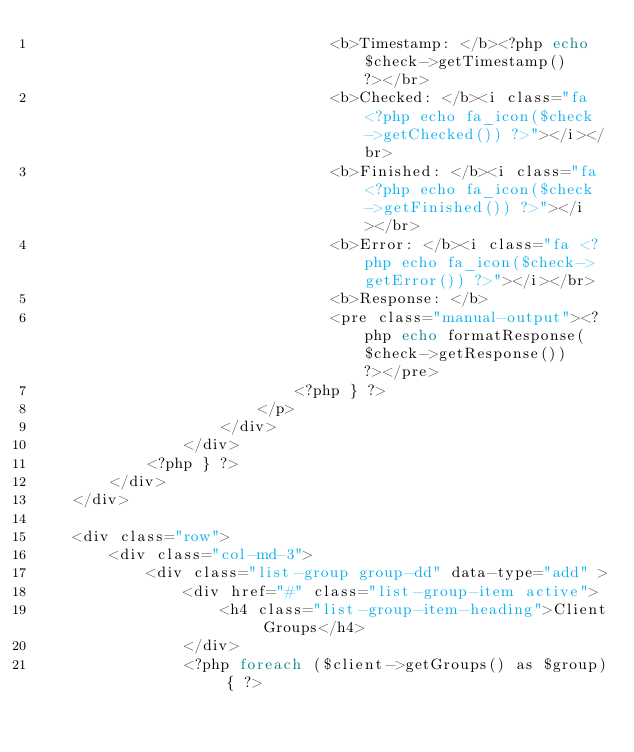<code> <loc_0><loc_0><loc_500><loc_500><_PHP_>                                <b>Timestamp: </b><?php echo $check->getTimestamp() ?></br>
                                <b>Checked: </b><i class="fa <?php echo fa_icon($check->getChecked()) ?>"></i></br>
                                <b>Finished: </b><i class="fa <?php echo fa_icon($check->getFinished()) ?>"></i></br>
                                <b>Error: </b><i class="fa <?php echo fa_icon($check->getError()) ?>"></i></br>
                                <b>Response: </b>
                                <pre class="manual-output"><?php echo formatResponse($check->getResponse()) ?></pre>
                            <?php } ?>
                        </p>
                    </div>
                </div>
            <?php } ?>
        </div>
    </div>
    
    <div class="row">
        <div class="col-md-3">
            <div class="list-group group-dd" data-type="add" >
                <div href="#" class="list-group-item active">
                    <h4 class="list-group-item-heading">Client Groups</h4>
                </div>
                <?php foreach ($client->getGroups() as $group) { ?></code> 